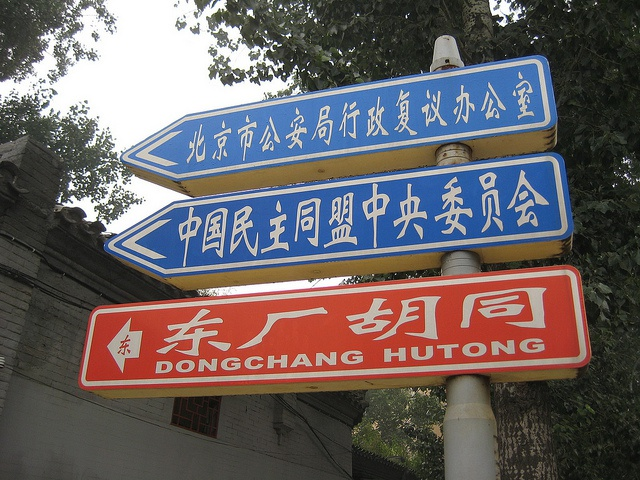Describe the objects in this image and their specific colors. I can see various objects in this image with different colors. 